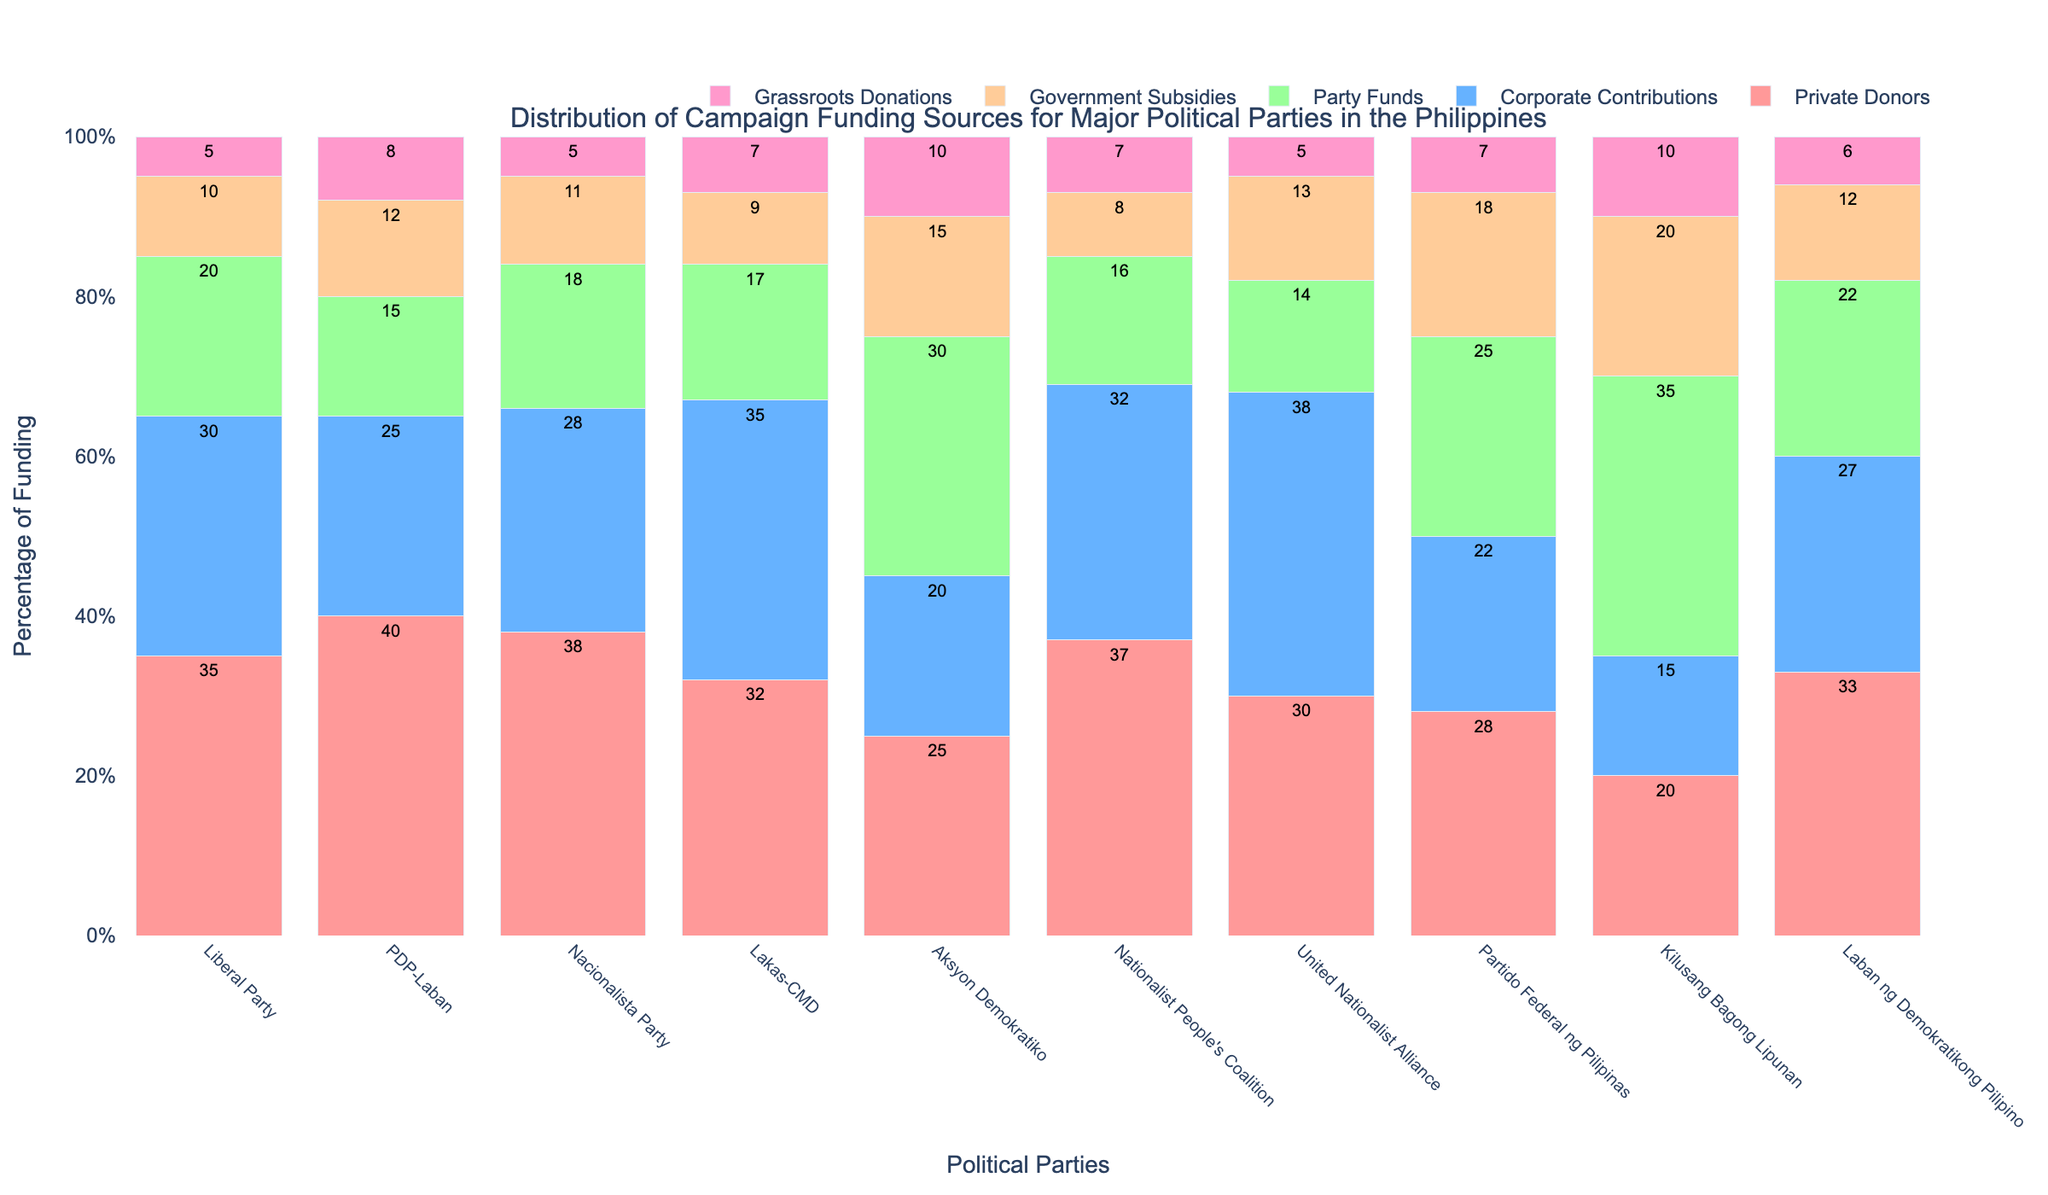Which party has the highest proportion of private donors in their campaign funding? By observing the heights of the bars representing private donors, PDP-Laban has the highest proportion at 40%.
Answer: PDP-Laban Which two parties have the smallest proportion of grassroots donations? The smallest proportions of grassroots donations can be observed visually by comparing the heights of the bars for grassroots donations. Both the Liberal Party and Nacionalista Party have the smallest proportion at 5%.
Answer: Liberal Party and Nacionalista Party What is the total percentage of funding from party funds and government subsidies for Aksyon Demokratiko? The proportion from Party Funds is 30% and from Government Subsidies is 15%. Adding these two values gives 30% + 15% = 45%.
Answer: 45% Which funding source is most uniformly distributed across all parties? By comparing the variability in the heights of the bars for each funding source, Private Donors seem to have the most uniform distribution, as their values range from 20% to 40%.
Answer: Private Donors How much more in percentage terms does Lakas-CMD receive from corporate contributions compared to Kilusang Bagong Lipunan? Lakas-CMD receives 35% from corporate contributions, while Kilusang Bagong Lipunan receives 15%. The difference is 35% - 15% = 20%.
Answer: 20% Which parties receive more than 30% of their funding from party funds? By examining the heights of the bars for Party Funds, Aksyon Demokratiko (30%) and Kilusang Bagong Lipunan (35%) receive more than 30% of their funding from this source.
Answer: Aksyon Demokratiko and Kilusang Bagong Lipunan Between Liberal Party and United Nationalist Alliance, which one relies more on government subsidies? By comparing the heights of the bars for government subsidies, United Nationalist Alliance receives 13%, while the Liberal Party receives 10%. Hence, United Nationalist Alliance relies more on government subsidies.
Answer: United Nationalist Alliance What is the combined percentage of private donors and corporate contributions for Nacionalista Party? The proportion from private donors is 38% and from corporate contributions is 28%. Adding these two values gives 38% + 28% = 66%.
Answer: 66% Which party has the most diverse sources of funding, considering the spread among different sources? By visually inspecting the spread among different funding sources, Kilusang Bagong Lipunan has a relatively balanced and diverse distribution among all five funding sources.
Answer: Kilusang Bagong Lipunan 